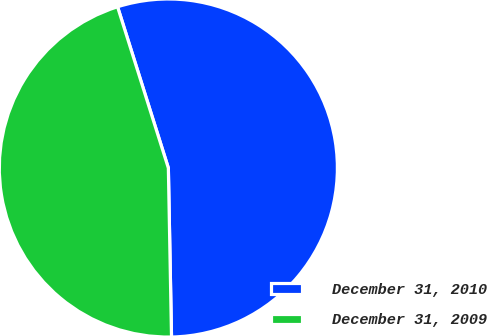Convert chart to OTSL. <chart><loc_0><loc_0><loc_500><loc_500><pie_chart><fcel>December 31, 2010<fcel>December 31, 2009<nl><fcel>54.56%<fcel>45.44%<nl></chart> 